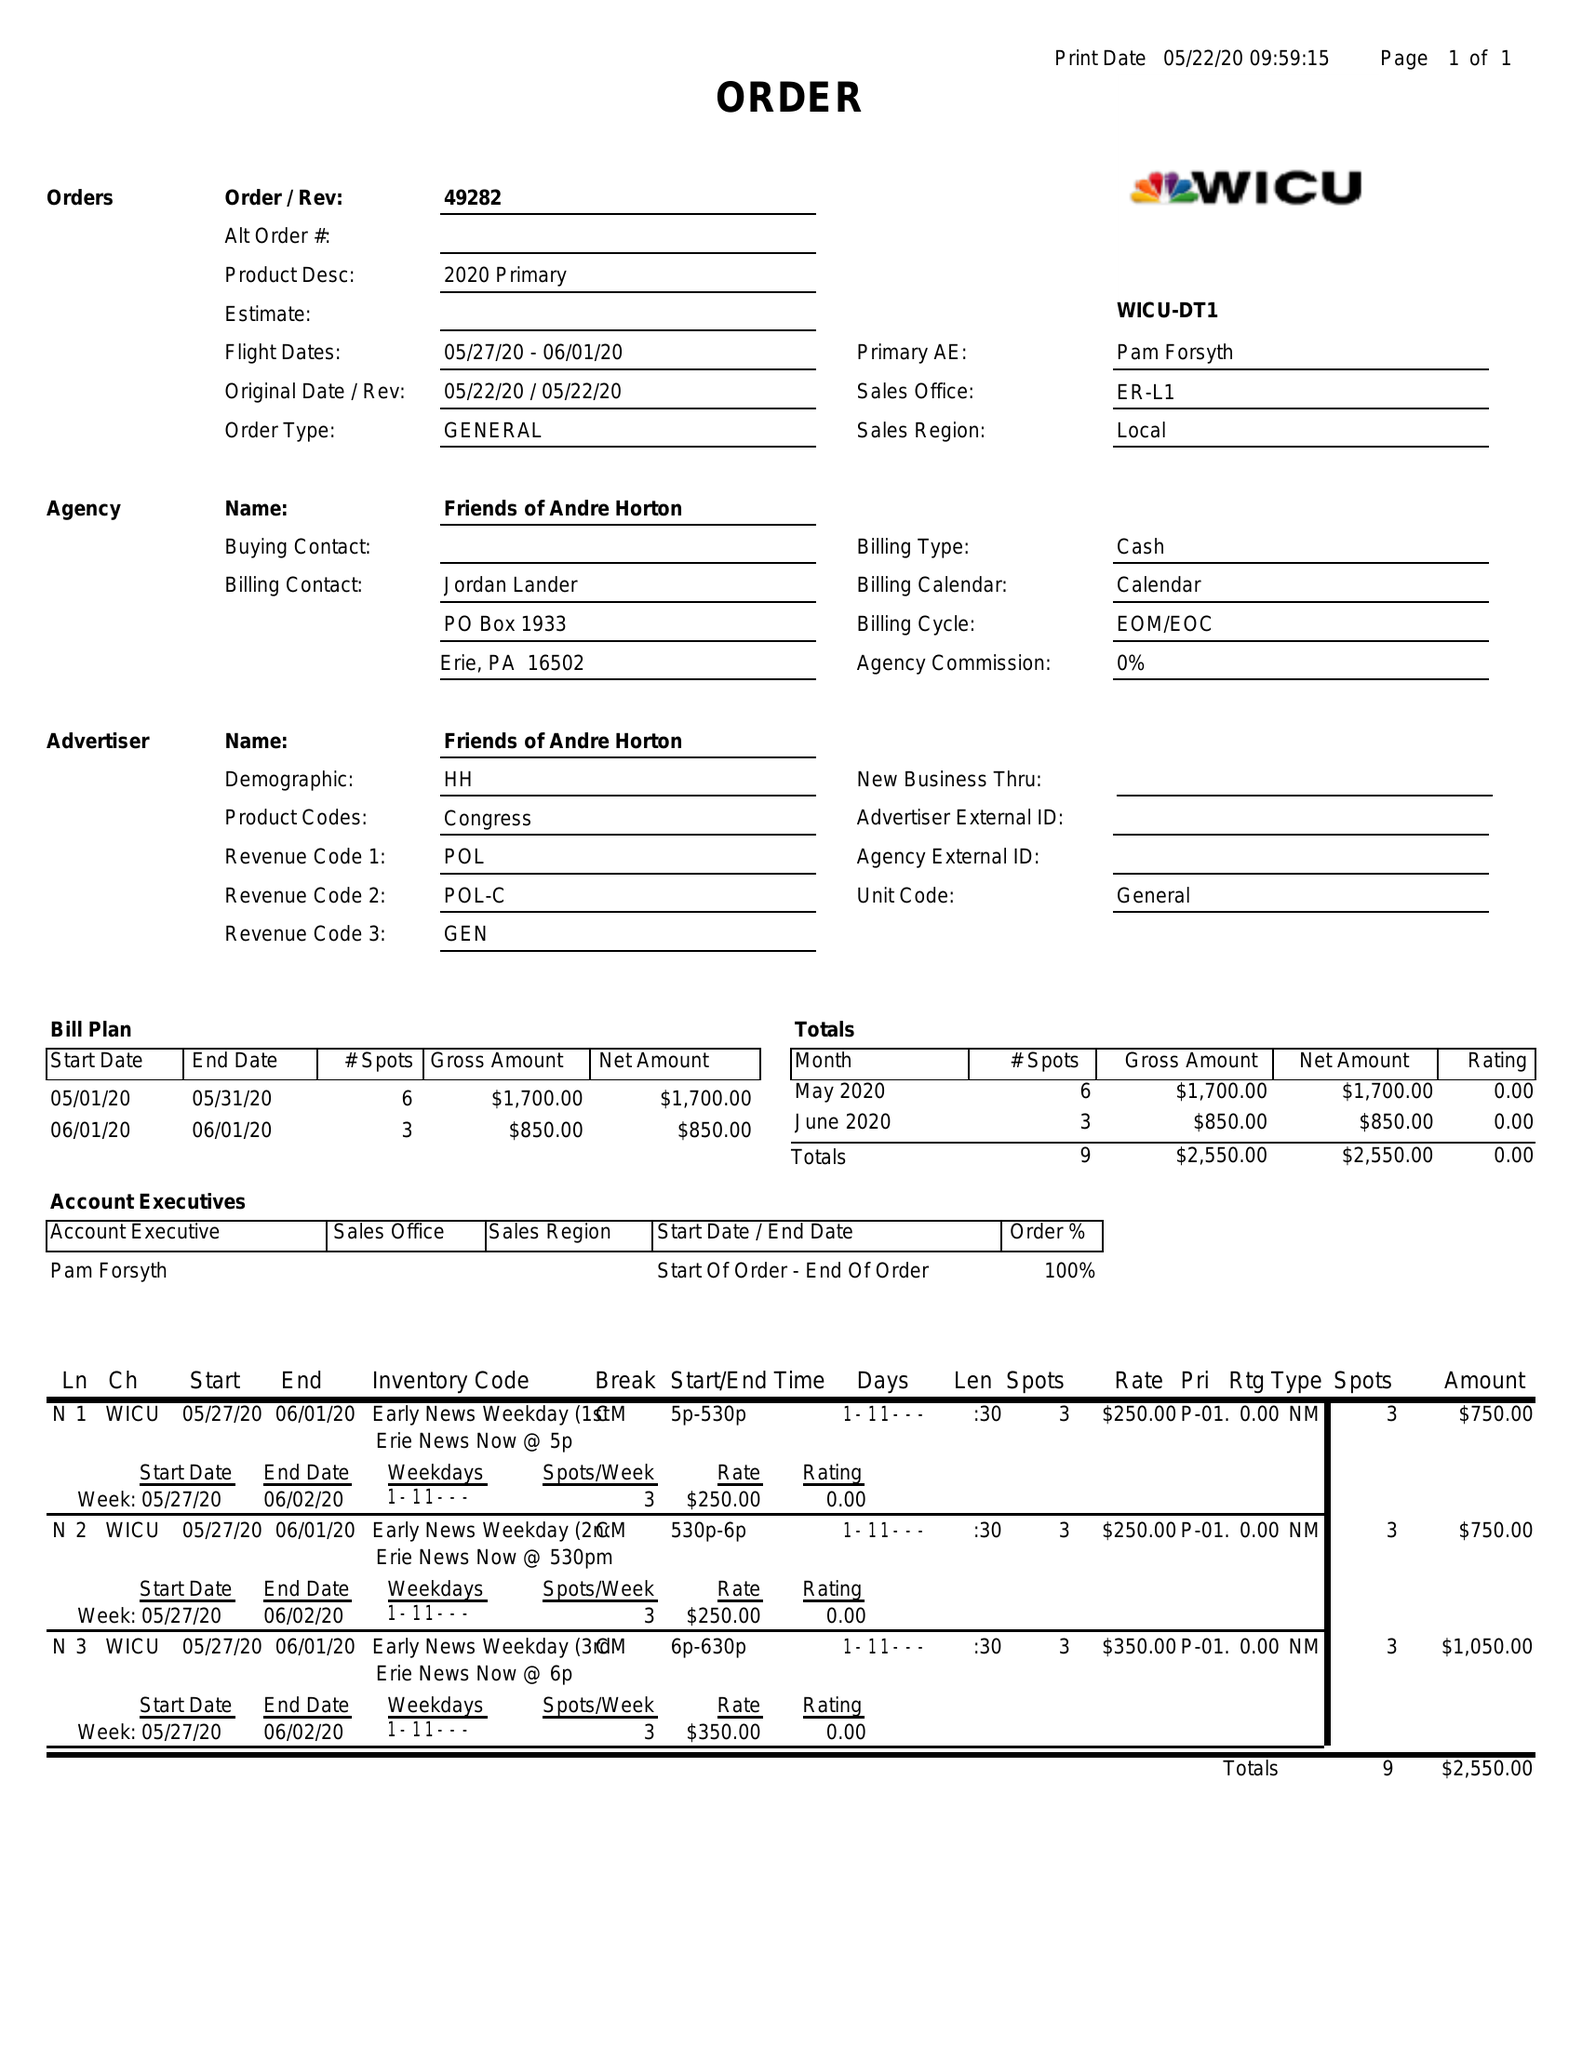What is the value for the gross_amount?
Answer the question using a single word or phrase. 2550.00 